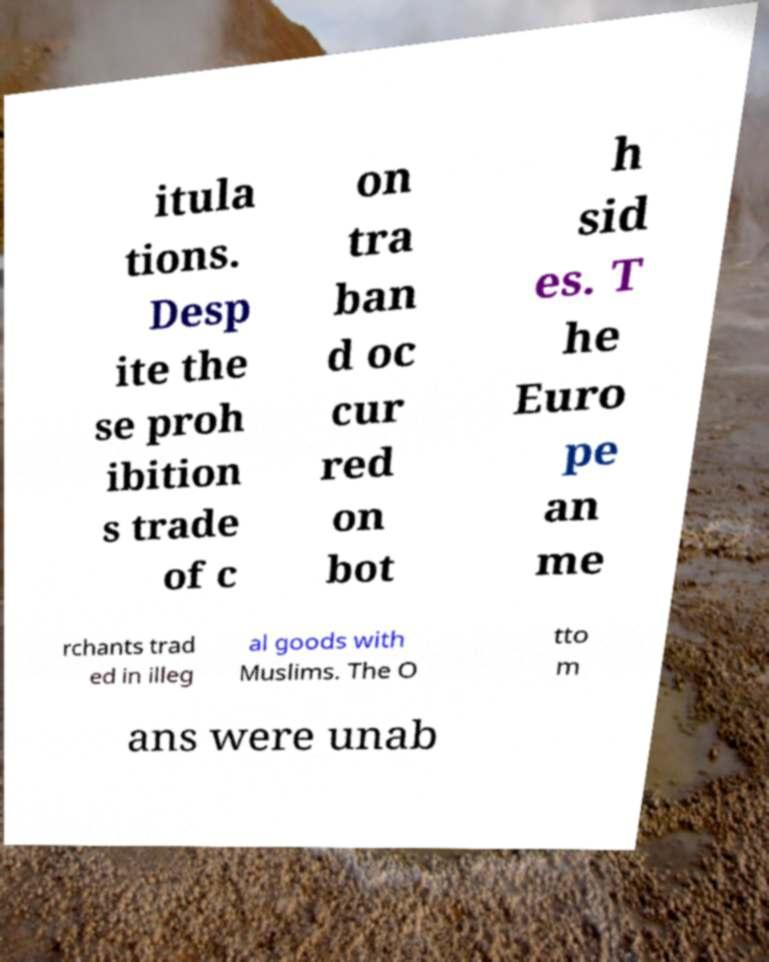Can you accurately transcribe the text from the provided image for me? itula tions. Desp ite the se proh ibition s trade of c on tra ban d oc cur red on bot h sid es. T he Euro pe an me rchants trad ed in illeg al goods with Muslims. The O tto m ans were unab 